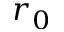<formula> <loc_0><loc_0><loc_500><loc_500>r _ { 0 }</formula> 